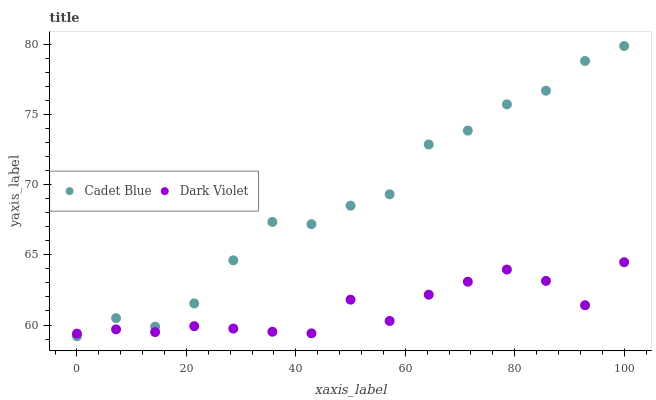Does Dark Violet have the minimum area under the curve?
Answer yes or no. Yes. Does Cadet Blue have the maximum area under the curve?
Answer yes or no. Yes. Does Dark Violet have the maximum area under the curve?
Answer yes or no. No. Is Cadet Blue the smoothest?
Answer yes or no. Yes. Is Dark Violet the roughest?
Answer yes or no. Yes. Is Dark Violet the smoothest?
Answer yes or no. No. Does Cadet Blue have the lowest value?
Answer yes or no. Yes. Does Dark Violet have the lowest value?
Answer yes or no. No. Does Cadet Blue have the highest value?
Answer yes or no. Yes. Does Dark Violet have the highest value?
Answer yes or no. No. Does Dark Violet intersect Cadet Blue?
Answer yes or no. Yes. Is Dark Violet less than Cadet Blue?
Answer yes or no. No. Is Dark Violet greater than Cadet Blue?
Answer yes or no. No. 